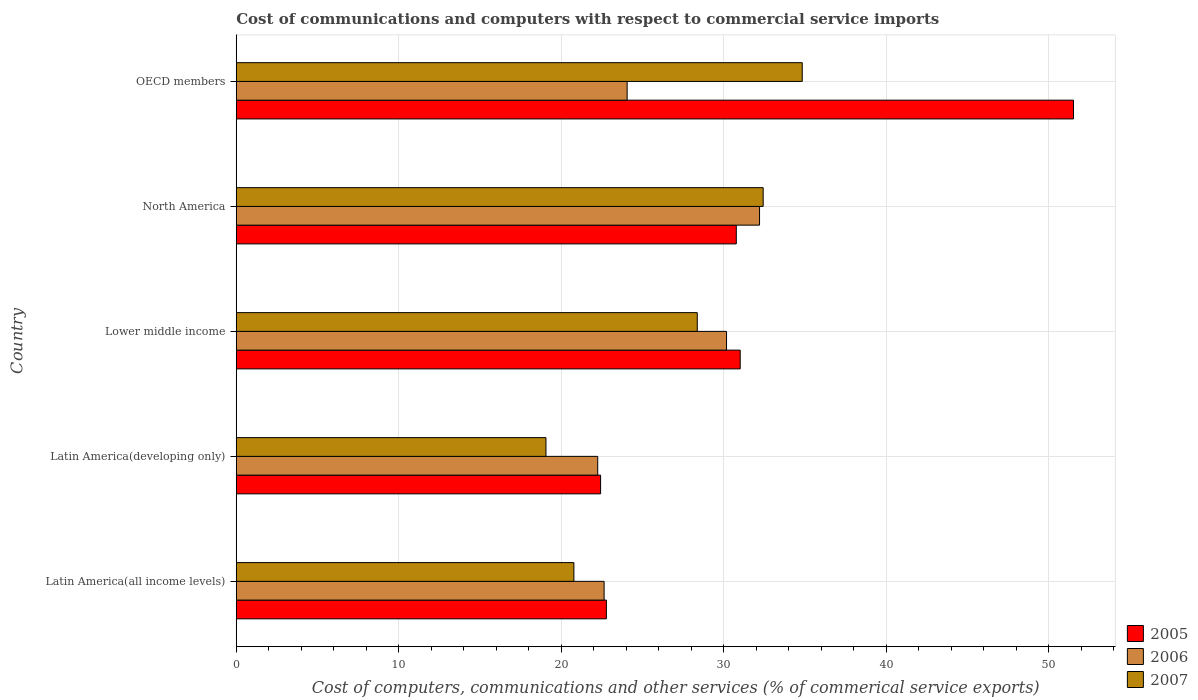Are the number of bars on each tick of the Y-axis equal?
Provide a succinct answer. Yes. How many bars are there on the 5th tick from the top?
Provide a short and direct response. 3. In how many cases, is the number of bars for a given country not equal to the number of legend labels?
Provide a short and direct response. 0. What is the cost of communications and computers in 2005 in OECD members?
Your response must be concise. 51.51. Across all countries, what is the maximum cost of communications and computers in 2007?
Ensure brevity in your answer.  34.82. Across all countries, what is the minimum cost of communications and computers in 2005?
Keep it short and to the point. 22.42. In which country was the cost of communications and computers in 2005 minimum?
Your response must be concise. Latin America(developing only). What is the total cost of communications and computers in 2007 in the graph?
Offer a terse response. 135.43. What is the difference between the cost of communications and computers in 2006 in Lower middle income and that in North America?
Offer a very short reply. -2.03. What is the difference between the cost of communications and computers in 2006 in Lower middle income and the cost of communications and computers in 2005 in OECD members?
Ensure brevity in your answer.  -21.35. What is the average cost of communications and computers in 2006 per country?
Ensure brevity in your answer.  26.26. What is the difference between the cost of communications and computers in 2006 and cost of communications and computers in 2007 in Lower middle income?
Your answer should be very brief. 1.8. What is the ratio of the cost of communications and computers in 2005 in Latin America(all income levels) to that in OECD members?
Your answer should be very brief. 0.44. Is the difference between the cost of communications and computers in 2006 in North America and OECD members greater than the difference between the cost of communications and computers in 2007 in North America and OECD members?
Keep it short and to the point. Yes. What is the difference between the highest and the second highest cost of communications and computers in 2005?
Offer a terse response. 20.51. What is the difference between the highest and the lowest cost of communications and computers in 2006?
Ensure brevity in your answer.  9.96. In how many countries, is the cost of communications and computers in 2006 greater than the average cost of communications and computers in 2006 taken over all countries?
Make the answer very short. 2. Is the sum of the cost of communications and computers in 2007 in North America and OECD members greater than the maximum cost of communications and computers in 2005 across all countries?
Keep it short and to the point. Yes. What does the 3rd bar from the bottom in Latin America(developing only) represents?
Provide a short and direct response. 2007. Is it the case that in every country, the sum of the cost of communications and computers in 2005 and cost of communications and computers in 2007 is greater than the cost of communications and computers in 2006?
Your response must be concise. Yes. How many bars are there?
Provide a short and direct response. 15. Are all the bars in the graph horizontal?
Provide a short and direct response. Yes. How many countries are there in the graph?
Your answer should be compact. 5. What is the difference between two consecutive major ticks on the X-axis?
Keep it short and to the point. 10. Does the graph contain any zero values?
Keep it short and to the point. No. What is the title of the graph?
Provide a short and direct response. Cost of communications and computers with respect to commercial service imports. What is the label or title of the X-axis?
Provide a succinct answer. Cost of computers, communications and other services (% of commerical service exports). What is the Cost of computers, communications and other services (% of commerical service exports) of 2005 in Latin America(all income levels)?
Give a very brief answer. 22.77. What is the Cost of computers, communications and other services (% of commerical service exports) of 2006 in Latin America(all income levels)?
Offer a very short reply. 22.63. What is the Cost of computers, communications and other services (% of commerical service exports) in 2007 in Latin America(all income levels)?
Keep it short and to the point. 20.77. What is the Cost of computers, communications and other services (% of commerical service exports) in 2005 in Latin America(developing only)?
Offer a terse response. 22.42. What is the Cost of computers, communications and other services (% of commerical service exports) in 2006 in Latin America(developing only)?
Give a very brief answer. 22.24. What is the Cost of computers, communications and other services (% of commerical service exports) in 2007 in Latin America(developing only)?
Offer a terse response. 19.05. What is the Cost of computers, communications and other services (% of commerical service exports) in 2005 in Lower middle income?
Your response must be concise. 31. What is the Cost of computers, communications and other services (% of commerical service exports) of 2006 in Lower middle income?
Provide a short and direct response. 30.16. What is the Cost of computers, communications and other services (% of commerical service exports) of 2007 in Lower middle income?
Offer a very short reply. 28.36. What is the Cost of computers, communications and other services (% of commerical service exports) in 2005 in North America?
Provide a short and direct response. 30.77. What is the Cost of computers, communications and other services (% of commerical service exports) in 2006 in North America?
Offer a very short reply. 32.2. What is the Cost of computers, communications and other services (% of commerical service exports) in 2007 in North America?
Keep it short and to the point. 32.42. What is the Cost of computers, communications and other services (% of commerical service exports) in 2005 in OECD members?
Keep it short and to the point. 51.51. What is the Cost of computers, communications and other services (% of commerical service exports) of 2006 in OECD members?
Give a very brief answer. 24.05. What is the Cost of computers, communications and other services (% of commerical service exports) of 2007 in OECD members?
Keep it short and to the point. 34.82. Across all countries, what is the maximum Cost of computers, communications and other services (% of commerical service exports) of 2005?
Offer a terse response. 51.51. Across all countries, what is the maximum Cost of computers, communications and other services (% of commerical service exports) in 2006?
Offer a terse response. 32.2. Across all countries, what is the maximum Cost of computers, communications and other services (% of commerical service exports) of 2007?
Give a very brief answer. 34.82. Across all countries, what is the minimum Cost of computers, communications and other services (% of commerical service exports) of 2005?
Offer a very short reply. 22.42. Across all countries, what is the minimum Cost of computers, communications and other services (% of commerical service exports) in 2006?
Your answer should be compact. 22.24. Across all countries, what is the minimum Cost of computers, communications and other services (% of commerical service exports) in 2007?
Your answer should be compact. 19.05. What is the total Cost of computers, communications and other services (% of commerical service exports) in 2005 in the graph?
Your answer should be compact. 158.47. What is the total Cost of computers, communications and other services (% of commerical service exports) of 2006 in the graph?
Make the answer very short. 131.28. What is the total Cost of computers, communications and other services (% of commerical service exports) in 2007 in the graph?
Offer a terse response. 135.43. What is the difference between the Cost of computers, communications and other services (% of commerical service exports) of 2005 in Latin America(all income levels) and that in Latin America(developing only)?
Your answer should be very brief. 0.36. What is the difference between the Cost of computers, communications and other services (% of commerical service exports) of 2006 in Latin America(all income levels) and that in Latin America(developing only)?
Make the answer very short. 0.39. What is the difference between the Cost of computers, communications and other services (% of commerical service exports) in 2007 in Latin America(all income levels) and that in Latin America(developing only)?
Your answer should be compact. 1.72. What is the difference between the Cost of computers, communications and other services (% of commerical service exports) of 2005 in Latin America(all income levels) and that in Lower middle income?
Your response must be concise. -8.23. What is the difference between the Cost of computers, communications and other services (% of commerical service exports) in 2006 in Latin America(all income levels) and that in Lower middle income?
Offer a terse response. -7.53. What is the difference between the Cost of computers, communications and other services (% of commerical service exports) in 2007 in Latin America(all income levels) and that in Lower middle income?
Provide a succinct answer. -7.59. What is the difference between the Cost of computers, communications and other services (% of commerical service exports) of 2005 in Latin America(all income levels) and that in North America?
Offer a terse response. -7.99. What is the difference between the Cost of computers, communications and other services (% of commerical service exports) in 2006 in Latin America(all income levels) and that in North America?
Give a very brief answer. -9.56. What is the difference between the Cost of computers, communications and other services (% of commerical service exports) of 2007 in Latin America(all income levels) and that in North America?
Offer a very short reply. -11.64. What is the difference between the Cost of computers, communications and other services (% of commerical service exports) of 2005 in Latin America(all income levels) and that in OECD members?
Offer a terse response. -28.74. What is the difference between the Cost of computers, communications and other services (% of commerical service exports) in 2006 in Latin America(all income levels) and that in OECD members?
Keep it short and to the point. -1.42. What is the difference between the Cost of computers, communications and other services (% of commerical service exports) in 2007 in Latin America(all income levels) and that in OECD members?
Keep it short and to the point. -14.05. What is the difference between the Cost of computers, communications and other services (% of commerical service exports) in 2005 in Latin America(developing only) and that in Lower middle income?
Provide a succinct answer. -8.59. What is the difference between the Cost of computers, communications and other services (% of commerical service exports) of 2006 in Latin America(developing only) and that in Lower middle income?
Keep it short and to the point. -7.93. What is the difference between the Cost of computers, communications and other services (% of commerical service exports) of 2007 in Latin America(developing only) and that in Lower middle income?
Make the answer very short. -9.31. What is the difference between the Cost of computers, communications and other services (% of commerical service exports) in 2005 in Latin America(developing only) and that in North America?
Your answer should be very brief. -8.35. What is the difference between the Cost of computers, communications and other services (% of commerical service exports) of 2006 in Latin America(developing only) and that in North America?
Your response must be concise. -9.96. What is the difference between the Cost of computers, communications and other services (% of commerical service exports) of 2007 in Latin America(developing only) and that in North America?
Ensure brevity in your answer.  -13.36. What is the difference between the Cost of computers, communications and other services (% of commerical service exports) of 2005 in Latin America(developing only) and that in OECD members?
Provide a short and direct response. -29.1. What is the difference between the Cost of computers, communications and other services (% of commerical service exports) of 2006 in Latin America(developing only) and that in OECD members?
Keep it short and to the point. -1.81. What is the difference between the Cost of computers, communications and other services (% of commerical service exports) in 2007 in Latin America(developing only) and that in OECD members?
Provide a short and direct response. -15.77. What is the difference between the Cost of computers, communications and other services (% of commerical service exports) of 2005 in Lower middle income and that in North America?
Ensure brevity in your answer.  0.24. What is the difference between the Cost of computers, communications and other services (% of commerical service exports) in 2006 in Lower middle income and that in North America?
Give a very brief answer. -2.03. What is the difference between the Cost of computers, communications and other services (% of commerical service exports) of 2007 in Lower middle income and that in North America?
Provide a succinct answer. -4.05. What is the difference between the Cost of computers, communications and other services (% of commerical service exports) of 2005 in Lower middle income and that in OECD members?
Make the answer very short. -20.51. What is the difference between the Cost of computers, communications and other services (% of commerical service exports) of 2006 in Lower middle income and that in OECD members?
Offer a very short reply. 6.12. What is the difference between the Cost of computers, communications and other services (% of commerical service exports) in 2007 in Lower middle income and that in OECD members?
Ensure brevity in your answer.  -6.46. What is the difference between the Cost of computers, communications and other services (% of commerical service exports) of 2005 in North America and that in OECD members?
Make the answer very short. -20.75. What is the difference between the Cost of computers, communications and other services (% of commerical service exports) in 2006 in North America and that in OECD members?
Provide a succinct answer. 8.15. What is the difference between the Cost of computers, communications and other services (% of commerical service exports) of 2007 in North America and that in OECD members?
Give a very brief answer. -2.4. What is the difference between the Cost of computers, communications and other services (% of commerical service exports) in 2005 in Latin America(all income levels) and the Cost of computers, communications and other services (% of commerical service exports) in 2006 in Latin America(developing only)?
Keep it short and to the point. 0.53. What is the difference between the Cost of computers, communications and other services (% of commerical service exports) of 2005 in Latin America(all income levels) and the Cost of computers, communications and other services (% of commerical service exports) of 2007 in Latin America(developing only)?
Your answer should be compact. 3.72. What is the difference between the Cost of computers, communications and other services (% of commerical service exports) of 2006 in Latin America(all income levels) and the Cost of computers, communications and other services (% of commerical service exports) of 2007 in Latin America(developing only)?
Your answer should be very brief. 3.58. What is the difference between the Cost of computers, communications and other services (% of commerical service exports) of 2005 in Latin America(all income levels) and the Cost of computers, communications and other services (% of commerical service exports) of 2006 in Lower middle income?
Your answer should be compact. -7.39. What is the difference between the Cost of computers, communications and other services (% of commerical service exports) of 2005 in Latin America(all income levels) and the Cost of computers, communications and other services (% of commerical service exports) of 2007 in Lower middle income?
Make the answer very short. -5.59. What is the difference between the Cost of computers, communications and other services (% of commerical service exports) of 2006 in Latin America(all income levels) and the Cost of computers, communications and other services (% of commerical service exports) of 2007 in Lower middle income?
Offer a terse response. -5.73. What is the difference between the Cost of computers, communications and other services (% of commerical service exports) of 2005 in Latin America(all income levels) and the Cost of computers, communications and other services (% of commerical service exports) of 2006 in North America?
Make the answer very short. -9.42. What is the difference between the Cost of computers, communications and other services (% of commerical service exports) of 2005 in Latin America(all income levels) and the Cost of computers, communications and other services (% of commerical service exports) of 2007 in North America?
Give a very brief answer. -9.65. What is the difference between the Cost of computers, communications and other services (% of commerical service exports) of 2006 in Latin America(all income levels) and the Cost of computers, communications and other services (% of commerical service exports) of 2007 in North America?
Provide a short and direct response. -9.79. What is the difference between the Cost of computers, communications and other services (% of commerical service exports) of 2005 in Latin America(all income levels) and the Cost of computers, communications and other services (% of commerical service exports) of 2006 in OECD members?
Keep it short and to the point. -1.28. What is the difference between the Cost of computers, communications and other services (% of commerical service exports) of 2005 in Latin America(all income levels) and the Cost of computers, communications and other services (% of commerical service exports) of 2007 in OECD members?
Your answer should be compact. -12.05. What is the difference between the Cost of computers, communications and other services (% of commerical service exports) in 2006 in Latin America(all income levels) and the Cost of computers, communications and other services (% of commerical service exports) in 2007 in OECD members?
Provide a short and direct response. -12.19. What is the difference between the Cost of computers, communications and other services (% of commerical service exports) of 2005 in Latin America(developing only) and the Cost of computers, communications and other services (% of commerical service exports) of 2006 in Lower middle income?
Your response must be concise. -7.75. What is the difference between the Cost of computers, communications and other services (% of commerical service exports) of 2005 in Latin America(developing only) and the Cost of computers, communications and other services (% of commerical service exports) of 2007 in Lower middle income?
Your answer should be compact. -5.95. What is the difference between the Cost of computers, communications and other services (% of commerical service exports) of 2006 in Latin America(developing only) and the Cost of computers, communications and other services (% of commerical service exports) of 2007 in Lower middle income?
Make the answer very short. -6.12. What is the difference between the Cost of computers, communications and other services (% of commerical service exports) in 2005 in Latin America(developing only) and the Cost of computers, communications and other services (% of commerical service exports) in 2006 in North America?
Give a very brief answer. -9.78. What is the difference between the Cost of computers, communications and other services (% of commerical service exports) in 2005 in Latin America(developing only) and the Cost of computers, communications and other services (% of commerical service exports) in 2007 in North America?
Your answer should be compact. -10. What is the difference between the Cost of computers, communications and other services (% of commerical service exports) of 2006 in Latin America(developing only) and the Cost of computers, communications and other services (% of commerical service exports) of 2007 in North America?
Keep it short and to the point. -10.18. What is the difference between the Cost of computers, communications and other services (% of commerical service exports) in 2005 in Latin America(developing only) and the Cost of computers, communications and other services (% of commerical service exports) in 2006 in OECD members?
Offer a terse response. -1.63. What is the difference between the Cost of computers, communications and other services (% of commerical service exports) of 2005 in Latin America(developing only) and the Cost of computers, communications and other services (% of commerical service exports) of 2007 in OECD members?
Give a very brief answer. -12.41. What is the difference between the Cost of computers, communications and other services (% of commerical service exports) of 2006 in Latin America(developing only) and the Cost of computers, communications and other services (% of commerical service exports) of 2007 in OECD members?
Your answer should be compact. -12.58. What is the difference between the Cost of computers, communications and other services (% of commerical service exports) of 2005 in Lower middle income and the Cost of computers, communications and other services (% of commerical service exports) of 2006 in North America?
Your answer should be compact. -1.19. What is the difference between the Cost of computers, communications and other services (% of commerical service exports) of 2005 in Lower middle income and the Cost of computers, communications and other services (% of commerical service exports) of 2007 in North America?
Provide a short and direct response. -1.41. What is the difference between the Cost of computers, communications and other services (% of commerical service exports) in 2006 in Lower middle income and the Cost of computers, communications and other services (% of commerical service exports) in 2007 in North America?
Your answer should be very brief. -2.25. What is the difference between the Cost of computers, communications and other services (% of commerical service exports) of 2005 in Lower middle income and the Cost of computers, communications and other services (% of commerical service exports) of 2006 in OECD members?
Your answer should be compact. 6.96. What is the difference between the Cost of computers, communications and other services (% of commerical service exports) of 2005 in Lower middle income and the Cost of computers, communications and other services (% of commerical service exports) of 2007 in OECD members?
Make the answer very short. -3.82. What is the difference between the Cost of computers, communications and other services (% of commerical service exports) of 2006 in Lower middle income and the Cost of computers, communications and other services (% of commerical service exports) of 2007 in OECD members?
Ensure brevity in your answer.  -4.66. What is the difference between the Cost of computers, communications and other services (% of commerical service exports) in 2005 in North America and the Cost of computers, communications and other services (% of commerical service exports) in 2006 in OECD members?
Ensure brevity in your answer.  6.72. What is the difference between the Cost of computers, communications and other services (% of commerical service exports) in 2005 in North America and the Cost of computers, communications and other services (% of commerical service exports) in 2007 in OECD members?
Your answer should be compact. -4.06. What is the difference between the Cost of computers, communications and other services (% of commerical service exports) of 2006 in North America and the Cost of computers, communications and other services (% of commerical service exports) of 2007 in OECD members?
Your answer should be compact. -2.63. What is the average Cost of computers, communications and other services (% of commerical service exports) in 2005 per country?
Provide a short and direct response. 31.69. What is the average Cost of computers, communications and other services (% of commerical service exports) in 2006 per country?
Your answer should be very brief. 26.26. What is the average Cost of computers, communications and other services (% of commerical service exports) in 2007 per country?
Offer a very short reply. 27.09. What is the difference between the Cost of computers, communications and other services (% of commerical service exports) of 2005 and Cost of computers, communications and other services (% of commerical service exports) of 2006 in Latin America(all income levels)?
Your response must be concise. 0.14. What is the difference between the Cost of computers, communications and other services (% of commerical service exports) of 2005 and Cost of computers, communications and other services (% of commerical service exports) of 2007 in Latin America(all income levels)?
Your response must be concise. 2. What is the difference between the Cost of computers, communications and other services (% of commerical service exports) in 2006 and Cost of computers, communications and other services (% of commerical service exports) in 2007 in Latin America(all income levels)?
Your response must be concise. 1.86. What is the difference between the Cost of computers, communications and other services (% of commerical service exports) of 2005 and Cost of computers, communications and other services (% of commerical service exports) of 2006 in Latin America(developing only)?
Make the answer very short. 0.18. What is the difference between the Cost of computers, communications and other services (% of commerical service exports) of 2005 and Cost of computers, communications and other services (% of commerical service exports) of 2007 in Latin America(developing only)?
Make the answer very short. 3.36. What is the difference between the Cost of computers, communications and other services (% of commerical service exports) in 2006 and Cost of computers, communications and other services (% of commerical service exports) in 2007 in Latin America(developing only)?
Keep it short and to the point. 3.18. What is the difference between the Cost of computers, communications and other services (% of commerical service exports) in 2005 and Cost of computers, communications and other services (% of commerical service exports) in 2006 in Lower middle income?
Provide a short and direct response. 0.84. What is the difference between the Cost of computers, communications and other services (% of commerical service exports) in 2005 and Cost of computers, communications and other services (% of commerical service exports) in 2007 in Lower middle income?
Ensure brevity in your answer.  2.64. What is the difference between the Cost of computers, communications and other services (% of commerical service exports) of 2006 and Cost of computers, communications and other services (% of commerical service exports) of 2007 in Lower middle income?
Keep it short and to the point. 1.8. What is the difference between the Cost of computers, communications and other services (% of commerical service exports) in 2005 and Cost of computers, communications and other services (% of commerical service exports) in 2006 in North America?
Your answer should be compact. -1.43. What is the difference between the Cost of computers, communications and other services (% of commerical service exports) in 2005 and Cost of computers, communications and other services (% of commerical service exports) in 2007 in North America?
Your answer should be compact. -1.65. What is the difference between the Cost of computers, communications and other services (% of commerical service exports) of 2006 and Cost of computers, communications and other services (% of commerical service exports) of 2007 in North America?
Offer a very short reply. -0.22. What is the difference between the Cost of computers, communications and other services (% of commerical service exports) of 2005 and Cost of computers, communications and other services (% of commerical service exports) of 2006 in OECD members?
Your response must be concise. 27.46. What is the difference between the Cost of computers, communications and other services (% of commerical service exports) in 2005 and Cost of computers, communications and other services (% of commerical service exports) in 2007 in OECD members?
Ensure brevity in your answer.  16.69. What is the difference between the Cost of computers, communications and other services (% of commerical service exports) in 2006 and Cost of computers, communications and other services (% of commerical service exports) in 2007 in OECD members?
Offer a very short reply. -10.77. What is the ratio of the Cost of computers, communications and other services (% of commerical service exports) in 2005 in Latin America(all income levels) to that in Latin America(developing only)?
Provide a short and direct response. 1.02. What is the ratio of the Cost of computers, communications and other services (% of commerical service exports) in 2006 in Latin America(all income levels) to that in Latin America(developing only)?
Your answer should be very brief. 1.02. What is the ratio of the Cost of computers, communications and other services (% of commerical service exports) of 2007 in Latin America(all income levels) to that in Latin America(developing only)?
Offer a terse response. 1.09. What is the ratio of the Cost of computers, communications and other services (% of commerical service exports) of 2005 in Latin America(all income levels) to that in Lower middle income?
Keep it short and to the point. 0.73. What is the ratio of the Cost of computers, communications and other services (% of commerical service exports) in 2006 in Latin America(all income levels) to that in Lower middle income?
Provide a short and direct response. 0.75. What is the ratio of the Cost of computers, communications and other services (% of commerical service exports) in 2007 in Latin America(all income levels) to that in Lower middle income?
Provide a short and direct response. 0.73. What is the ratio of the Cost of computers, communications and other services (% of commerical service exports) in 2005 in Latin America(all income levels) to that in North America?
Keep it short and to the point. 0.74. What is the ratio of the Cost of computers, communications and other services (% of commerical service exports) in 2006 in Latin America(all income levels) to that in North America?
Offer a terse response. 0.7. What is the ratio of the Cost of computers, communications and other services (% of commerical service exports) in 2007 in Latin America(all income levels) to that in North America?
Your answer should be very brief. 0.64. What is the ratio of the Cost of computers, communications and other services (% of commerical service exports) in 2005 in Latin America(all income levels) to that in OECD members?
Your answer should be compact. 0.44. What is the ratio of the Cost of computers, communications and other services (% of commerical service exports) of 2006 in Latin America(all income levels) to that in OECD members?
Keep it short and to the point. 0.94. What is the ratio of the Cost of computers, communications and other services (% of commerical service exports) of 2007 in Latin America(all income levels) to that in OECD members?
Give a very brief answer. 0.6. What is the ratio of the Cost of computers, communications and other services (% of commerical service exports) of 2005 in Latin America(developing only) to that in Lower middle income?
Your answer should be very brief. 0.72. What is the ratio of the Cost of computers, communications and other services (% of commerical service exports) in 2006 in Latin America(developing only) to that in Lower middle income?
Your response must be concise. 0.74. What is the ratio of the Cost of computers, communications and other services (% of commerical service exports) in 2007 in Latin America(developing only) to that in Lower middle income?
Offer a very short reply. 0.67. What is the ratio of the Cost of computers, communications and other services (% of commerical service exports) in 2005 in Latin America(developing only) to that in North America?
Make the answer very short. 0.73. What is the ratio of the Cost of computers, communications and other services (% of commerical service exports) of 2006 in Latin America(developing only) to that in North America?
Your response must be concise. 0.69. What is the ratio of the Cost of computers, communications and other services (% of commerical service exports) in 2007 in Latin America(developing only) to that in North America?
Provide a succinct answer. 0.59. What is the ratio of the Cost of computers, communications and other services (% of commerical service exports) of 2005 in Latin America(developing only) to that in OECD members?
Keep it short and to the point. 0.44. What is the ratio of the Cost of computers, communications and other services (% of commerical service exports) of 2006 in Latin America(developing only) to that in OECD members?
Ensure brevity in your answer.  0.92. What is the ratio of the Cost of computers, communications and other services (% of commerical service exports) of 2007 in Latin America(developing only) to that in OECD members?
Ensure brevity in your answer.  0.55. What is the ratio of the Cost of computers, communications and other services (% of commerical service exports) of 2005 in Lower middle income to that in North America?
Ensure brevity in your answer.  1.01. What is the ratio of the Cost of computers, communications and other services (% of commerical service exports) of 2006 in Lower middle income to that in North America?
Give a very brief answer. 0.94. What is the ratio of the Cost of computers, communications and other services (% of commerical service exports) of 2007 in Lower middle income to that in North America?
Keep it short and to the point. 0.87. What is the ratio of the Cost of computers, communications and other services (% of commerical service exports) of 2005 in Lower middle income to that in OECD members?
Your answer should be compact. 0.6. What is the ratio of the Cost of computers, communications and other services (% of commerical service exports) in 2006 in Lower middle income to that in OECD members?
Your response must be concise. 1.25. What is the ratio of the Cost of computers, communications and other services (% of commerical service exports) in 2007 in Lower middle income to that in OECD members?
Your answer should be very brief. 0.81. What is the ratio of the Cost of computers, communications and other services (% of commerical service exports) in 2005 in North America to that in OECD members?
Give a very brief answer. 0.6. What is the ratio of the Cost of computers, communications and other services (% of commerical service exports) in 2006 in North America to that in OECD members?
Your answer should be very brief. 1.34. What is the difference between the highest and the second highest Cost of computers, communications and other services (% of commerical service exports) of 2005?
Keep it short and to the point. 20.51. What is the difference between the highest and the second highest Cost of computers, communications and other services (% of commerical service exports) in 2006?
Offer a very short reply. 2.03. What is the difference between the highest and the second highest Cost of computers, communications and other services (% of commerical service exports) of 2007?
Give a very brief answer. 2.4. What is the difference between the highest and the lowest Cost of computers, communications and other services (% of commerical service exports) of 2005?
Give a very brief answer. 29.1. What is the difference between the highest and the lowest Cost of computers, communications and other services (% of commerical service exports) in 2006?
Provide a succinct answer. 9.96. What is the difference between the highest and the lowest Cost of computers, communications and other services (% of commerical service exports) in 2007?
Keep it short and to the point. 15.77. 